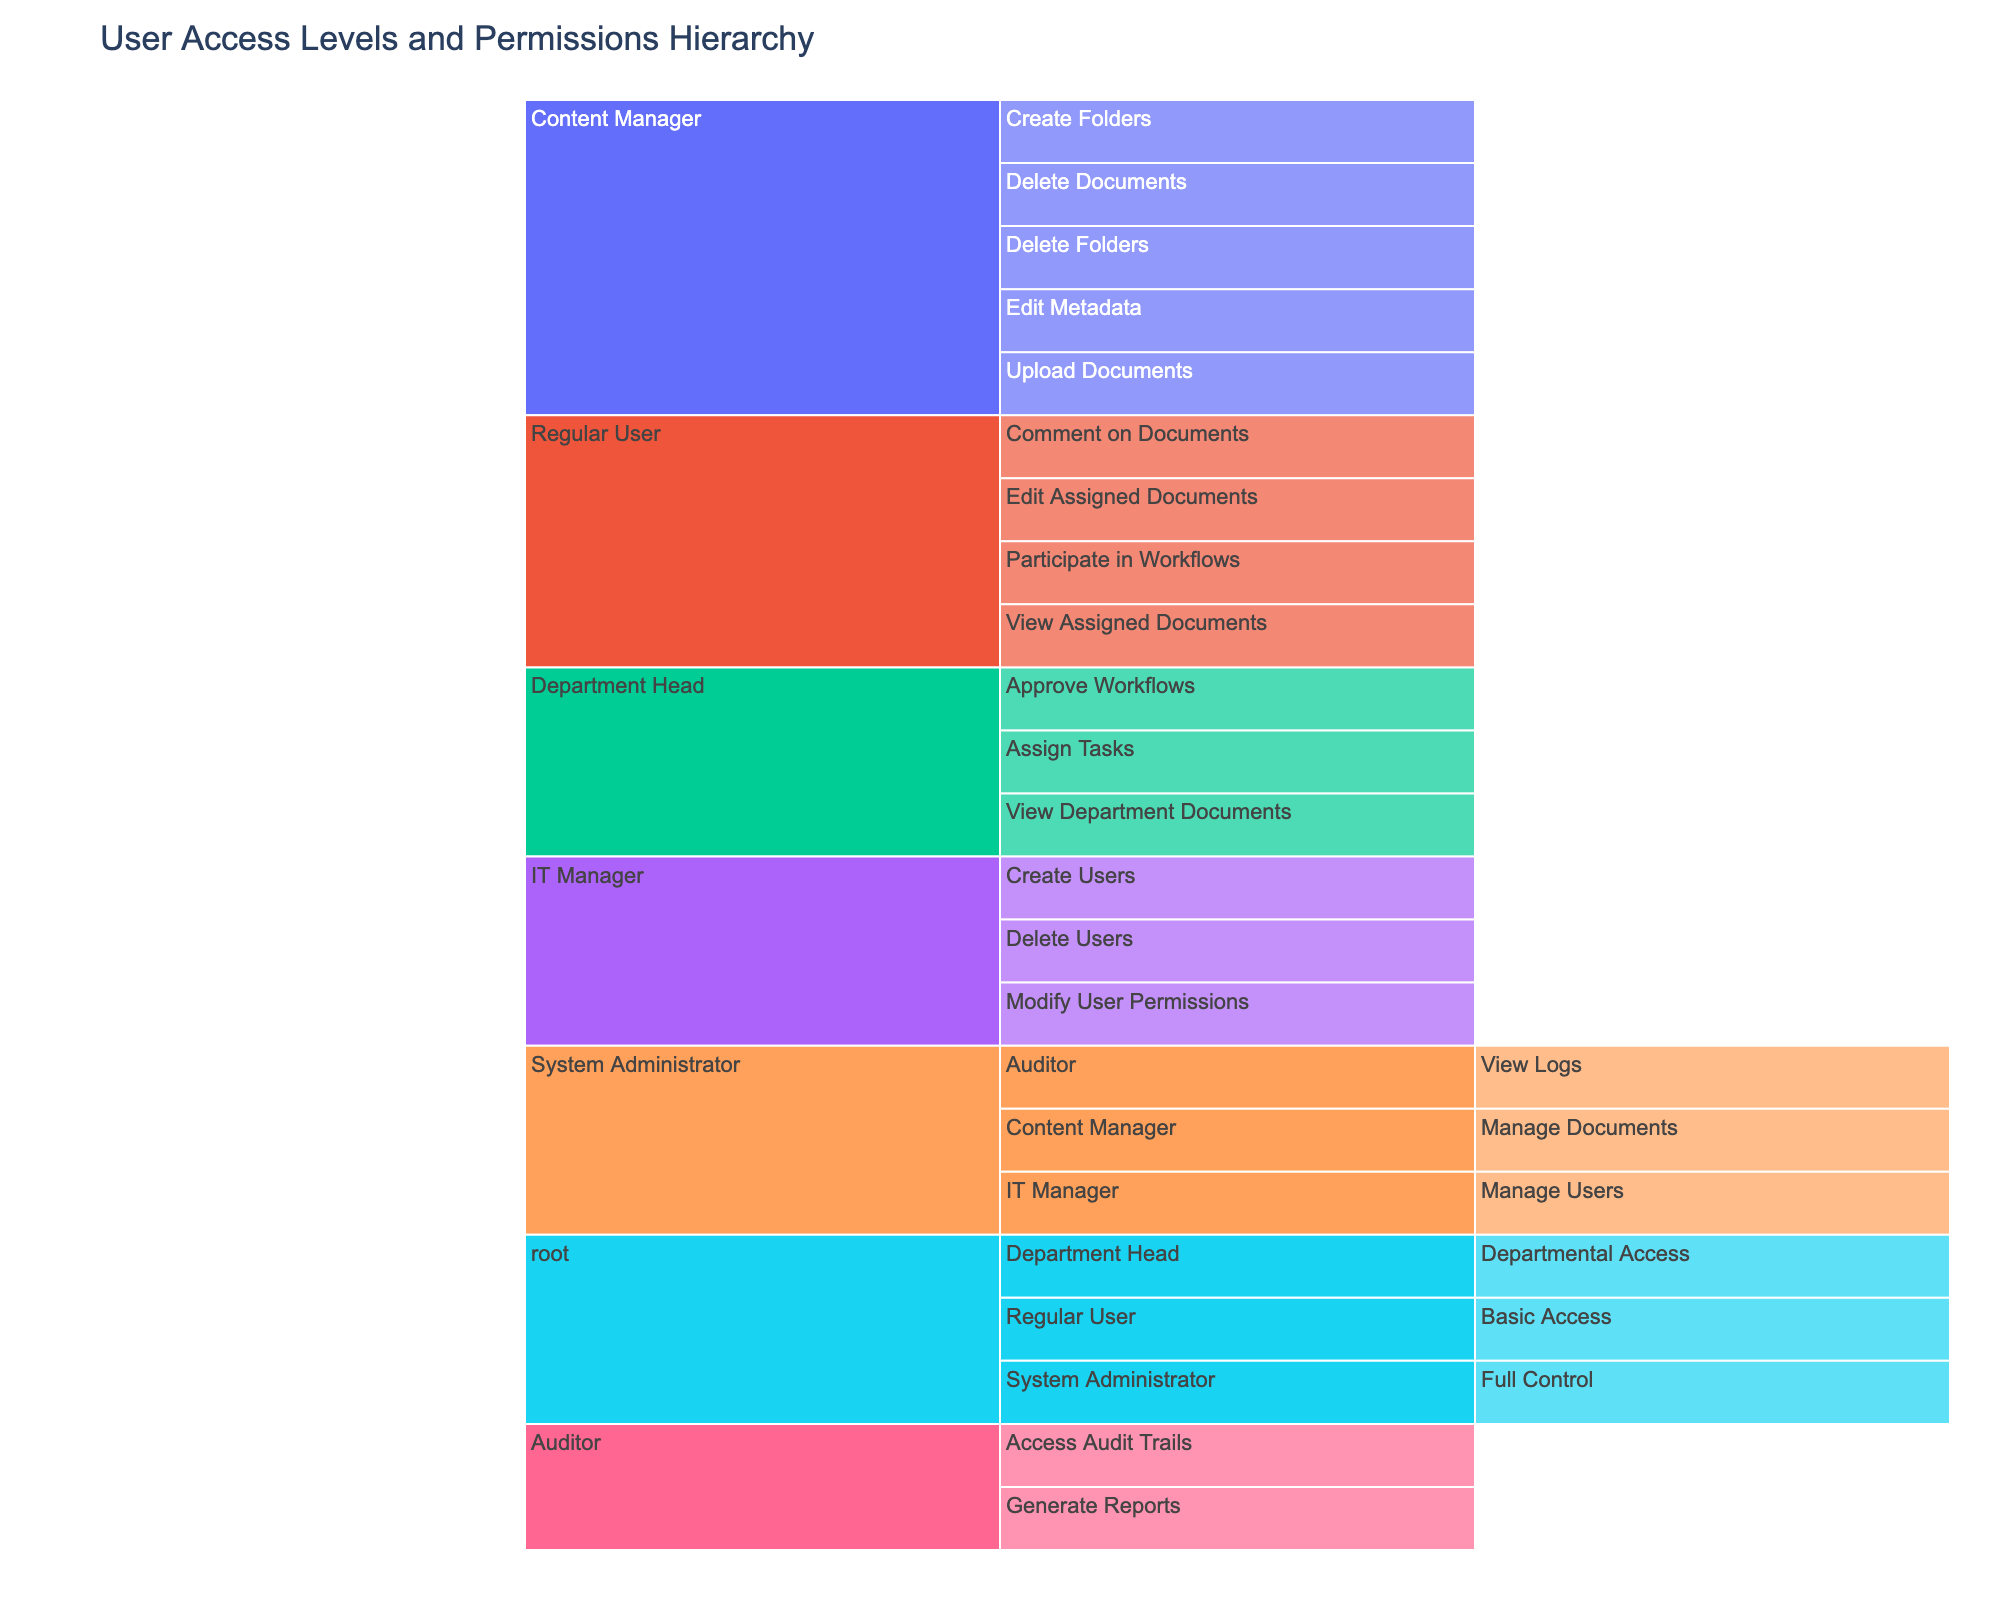What is the title of the chart? The title of the chart is displayed at the top of the figure and is intended to give an overall description of what the chart represents. Here, the title can be directly seen.
Answer: User Access Levels and Permissions Hierarchy How many access levels are under the System Administrator? By counting the distinct access levels listed under the System Administrator node in the hierarchy, we can determine the number.
Answer: 3 How many permissions are listed under the Content Manager? By examining the figure, count the number of distinct permissions listed under the Content Manager node.
Answer: 5 Which access level has the permission to delete users? Find the path that includes the 'Delete Users' permission to identify its associated access level.
Answer: IT Manager What permissions do Regular Users have? By following the hierarchy under the Regular User node, list all the permissions associated with it.
Answer: View Assigned Documents, Edit Assigned Documents, Comment on Documents, Participate in Workflows Which role is responsible for generating reports? Locate the path that includes the 'Generate Reports' permission to identify which role has this permission.
Answer: Auditor Compare the number of permissions available to the System Administrator and the Department Head. Which one has more? Count the permissions under each role and compare the totals. For the System Administrator, there are 9 permissions (including sub-roles); for the Department Head, there are 6 permissions.
Answer: System Administrator How many total nodes are present in the chart, including all levels and permissions? By summing up all distinct nodes presented at various levels of the hierarchy, we count the total.
Answer: 17 Which access level comes directly under the root node? Identify the first layer of nodes directly connected to the root node. These would be System Administrator, Department Head, and Regular User.
Answer: System Administrator, Department Head, Regular User Is there any permission listed that does not fall under any access level? Check all permissions to see if each one is associated with an access level in the hierarchy.
Answer: No 